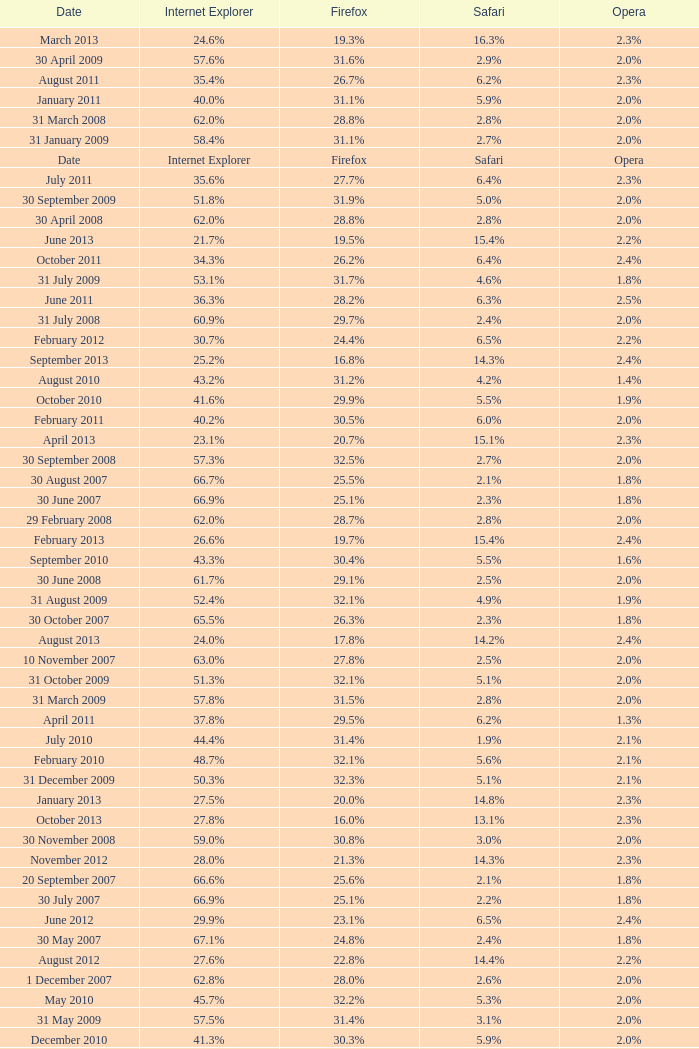What is the safari value with a 28.0% internet explorer? 14.3%. 